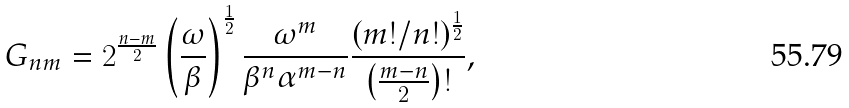Convert formula to latex. <formula><loc_0><loc_0><loc_500><loc_500>G _ { n m } = 2 ^ { \frac { n - m } { 2 } } \left ( \frac { \omega } { \beta } \right ) ^ { \frac { 1 } { 2 } } \frac { \omega ^ { m } } { \beta ^ { n } \alpha ^ { m - n } } \frac { ( m ! / n ! ) ^ { \frac { 1 } { 2 } } } { \left ( \frac { m - n } { 2 } \right ) ! } ,</formula> 